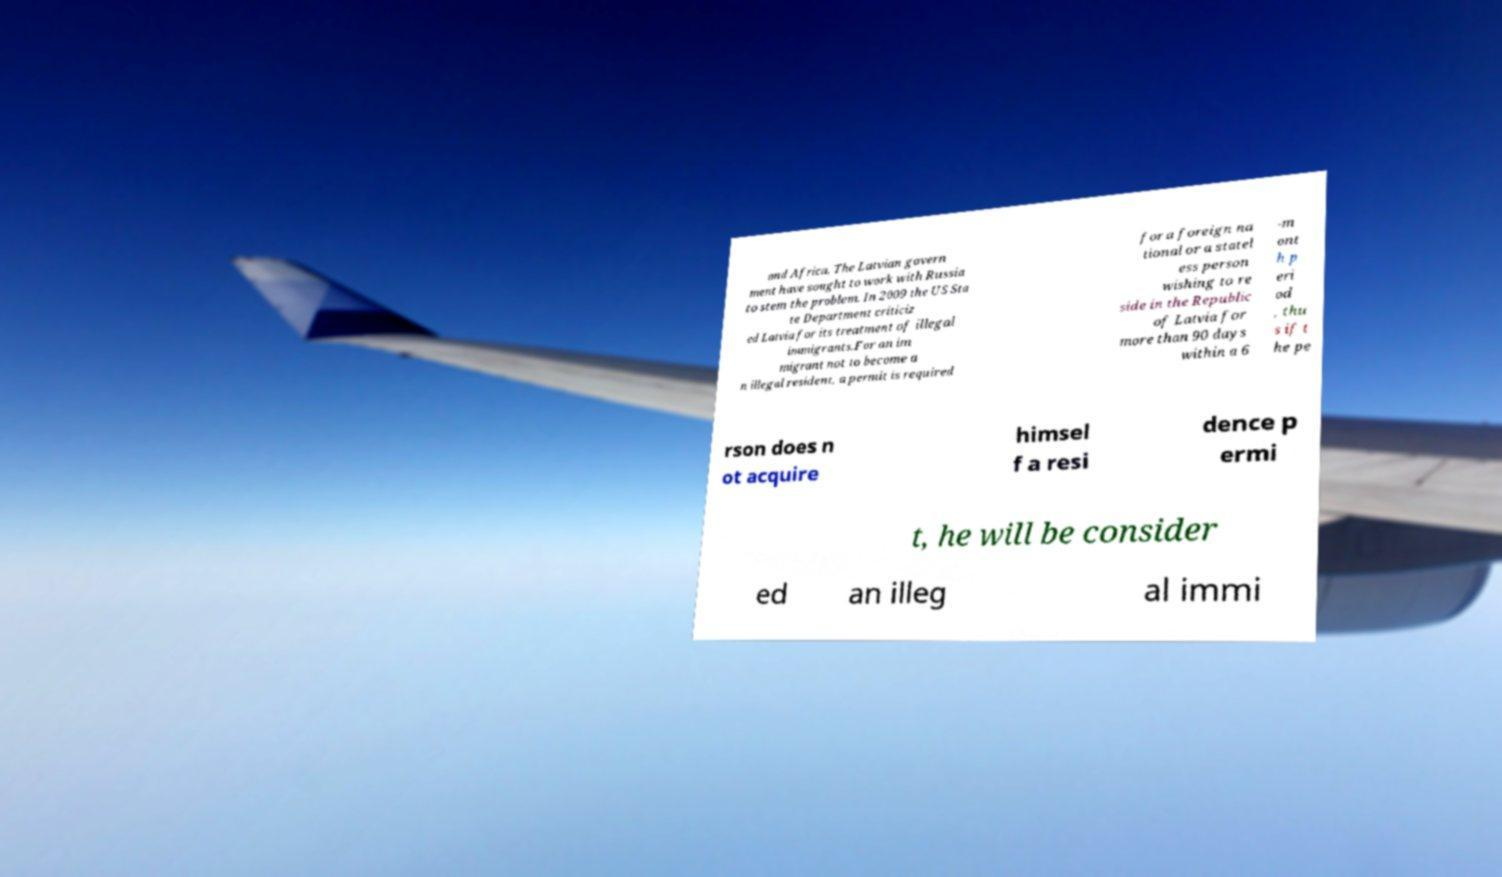Can you accurately transcribe the text from the provided image for me? and Africa. The Latvian govern ment have sought to work with Russia to stem the problem. In 2009 the US Sta te Department criticiz ed Latvia for its treatment of illegal immigrants.For an im migrant not to become a n illegal resident, a permit is required for a foreign na tional or a statel ess person wishing to re side in the Republic of Latvia for more than 90 days within a 6 -m ont h p eri od , thu s if t he pe rson does n ot acquire himsel f a resi dence p ermi t, he will be consider ed an illeg al immi 